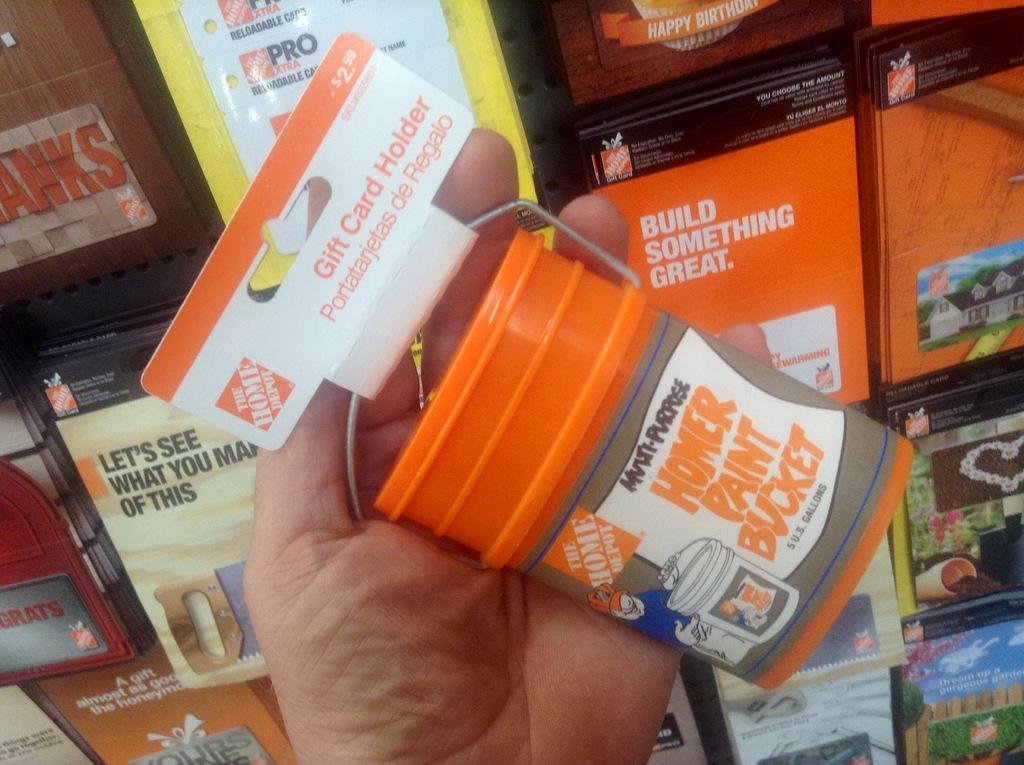<image>
Render a clear and concise summary of the photo. A hand holding a Home Depot gift card holder shaped like a Homer paint bucket. 